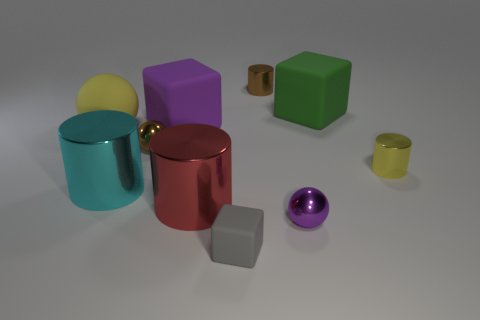Subtract all cylinders. How many objects are left? 6 Add 2 green cubes. How many green cubes exist? 3 Subtract 0 purple cylinders. How many objects are left? 10 Subtract all cyan metal cylinders. Subtract all tiny brown metallic spheres. How many objects are left? 8 Add 7 large yellow spheres. How many large yellow spheres are left? 8 